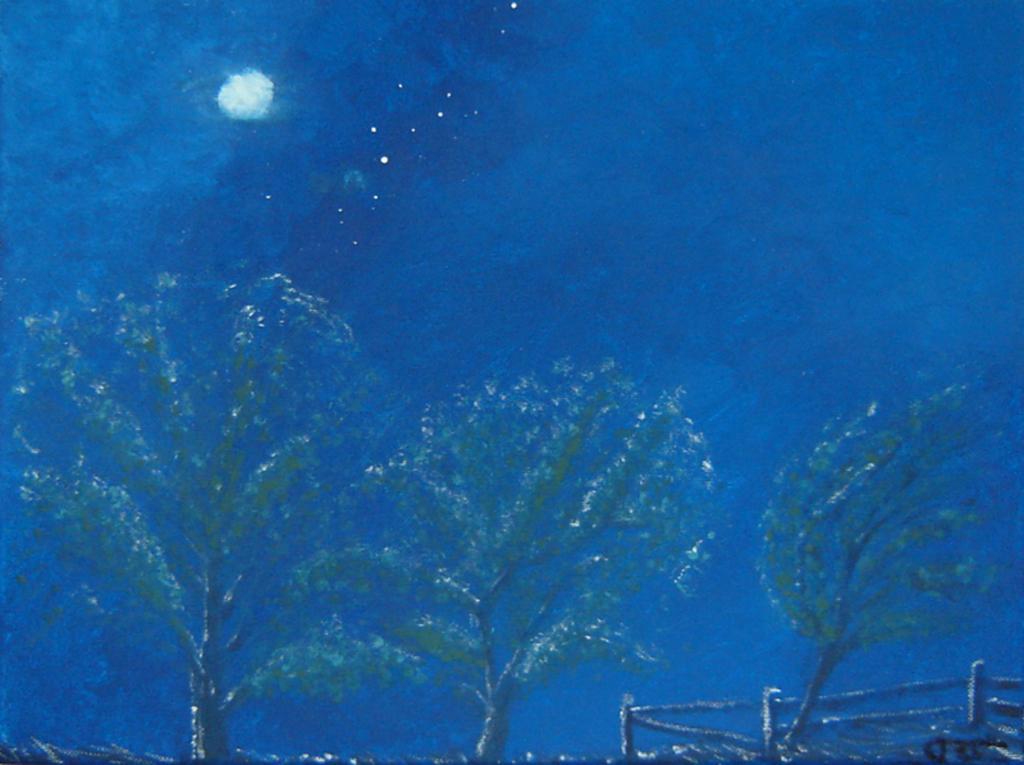Please provide a concise description of this image. In this image I can see painting of trees, moon, stars and sky. 